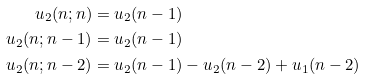<formula> <loc_0><loc_0><loc_500><loc_500>u _ { 2 } ( n ; n ) & = u _ { 2 } ( n - 1 ) \\ u _ { 2 } ( n ; n - 1 ) & = u _ { 2 } ( n - 1 ) \\ u _ { 2 } ( n ; n - 2 ) & = u _ { 2 } ( n - 1 ) - u _ { 2 } ( n - 2 ) + u _ { 1 } ( n - 2 )</formula> 